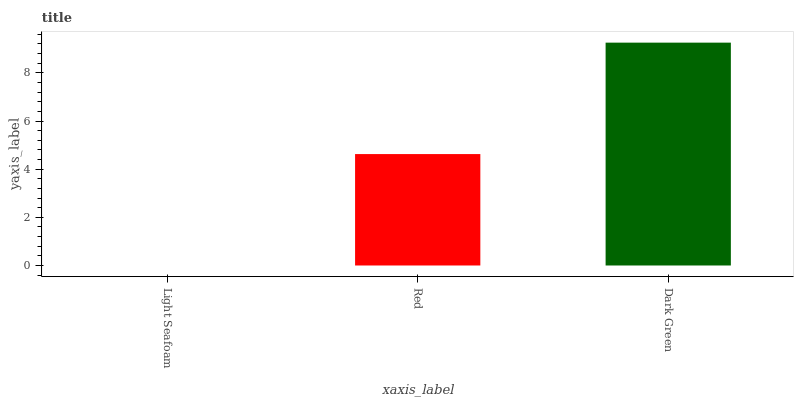Is Red the minimum?
Answer yes or no. No. Is Red the maximum?
Answer yes or no. No. Is Red greater than Light Seafoam?
Answer yes or no. Yes. Is Light Seafoam less than Red?
Answer yes or no. Yes. Is Light Seafoam greater than Red?
Answer yes or no. No. Is Red less than Light Seafoam?
Answer yes or no. No. Is Red the high median?
Answer yes or no. Yes. Is Red the low median?
Answer yes or no. Yes. Is Dark Green the high median?
Answer yes or no. No. Is Dark Green the low median?
Answer yes or no. No. 